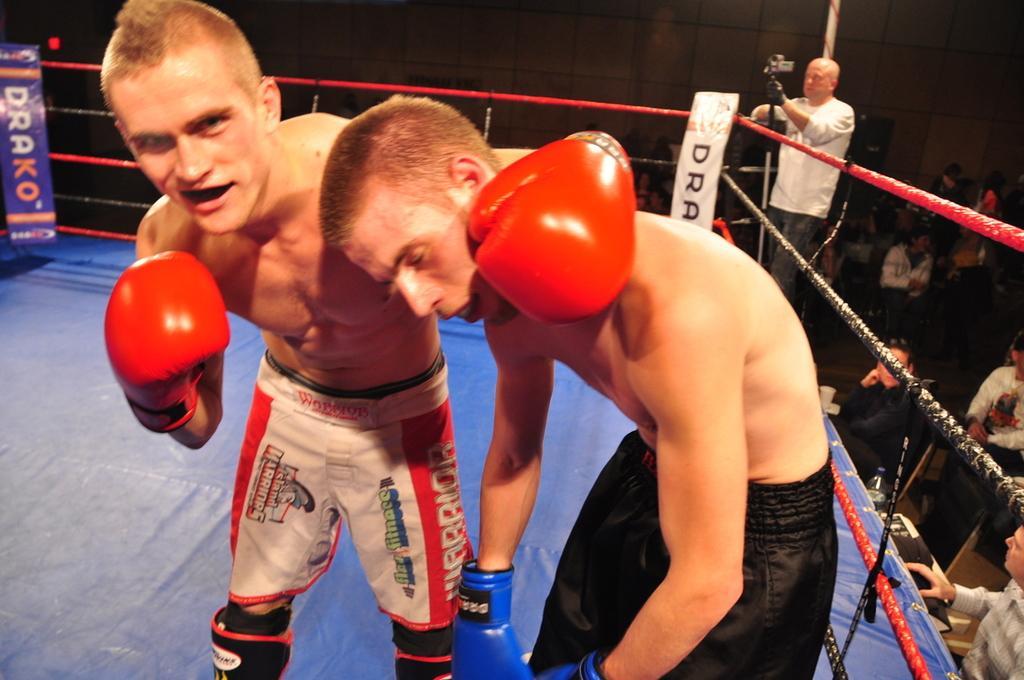Can you describe this image briefly? Here a wrestler is standing, he wore a black color short. In the left side another wrestler is standing and he wore a red and white color short. 